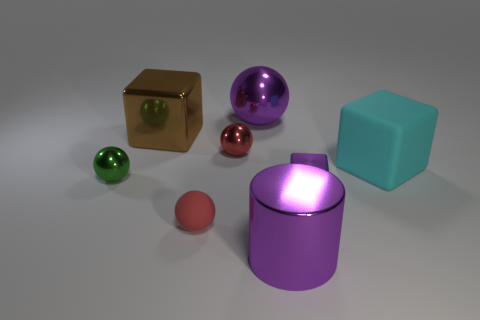Is the number of cyan cubes left of the large brown thing the same as the number of large brown metallic things?
Offer a terse response. No. What shape is the small shiny object that is both right of the brown metal block and behind the purple cube?
Make the answer very short. Sphere. Does the cylinder have the same size as the brown thing?
Your response must be concise. Yes. Are there any cylinders that have the same material as the cyan thing?
Offer a terse response. No. There is a shiny sphere that is the same color as the big cylinder; what is its size?
Keep it short and to the point. Large. How many big metallic things are both right of the red rubber thing and behind the large rubber block?
Provide a succinct answer. 1. There is a big brown block behind the small metal cube; what material is it?
Offer a very short reply. Metal. How many small shiny objects are the same color as the large metal cylinder?
Provide a succinct answer. 1. What is the size of the brown thing that is made of the same material as the big ball?
Your answer should be very brief. Large. How many things are large purple shiny balls or brown shiny cubes?
Keep it short and to the point. 2. 